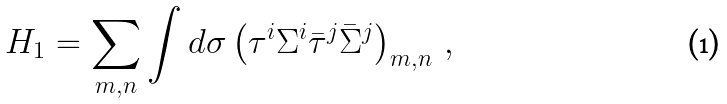Convert formula to latex. <formula><loc_0><loc_0><loc_500><loc_500>H _ { 1 } = \sum _ { m , n } \int d \sigma \left ( \tau ^ { i } \Sigma ^ { i } \bar { \tau } ^ { j } \bar { \Sigma } ^ { j } \right ) _ { m , n } \, ,</formula> 